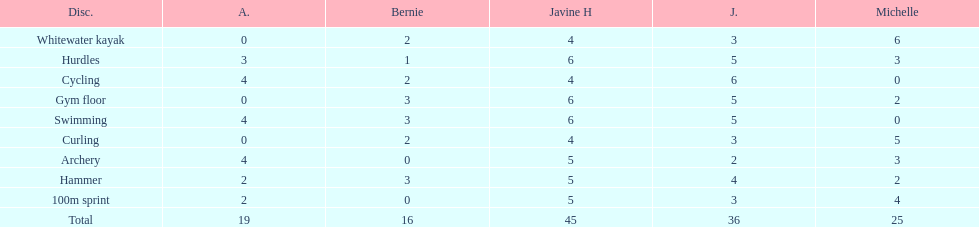Name a girl that had the same score in cycling and archery. Amanda. 